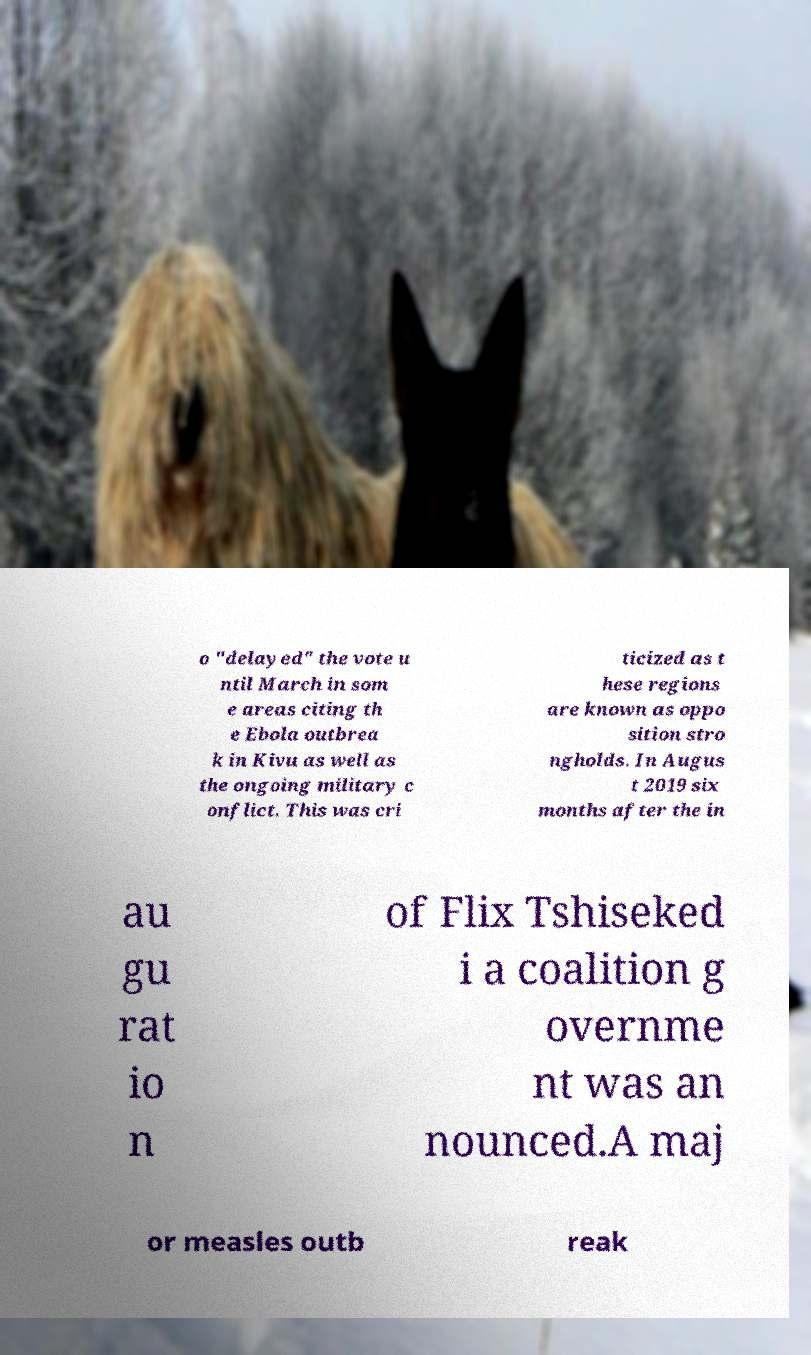What messages or text are displayed in this image? I need them in a readable, typed format. o "delayed" the vote u ntil March in som e areas citing th e Ebola outbrea k in Kivu as well as the ongoing military c onflict. This was cri ticized as t hese regions are known as oppo sition stro ngholds. In Augus t 2019 six months after the in au gu rat io n of Flix Tshiseked i a coalition g overnme nt was an nounced.A maj or measles outb reak 